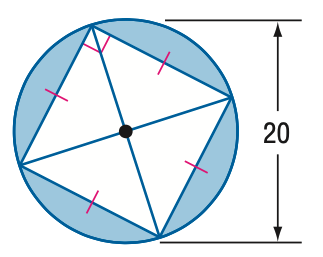Answer the mathemtical geometry problem and directly provide the correct option letter.
Question: Find the area of the blue region.
Choices: A: 85.8 B: 114.2 C: 214.2 D: 228.4 B 